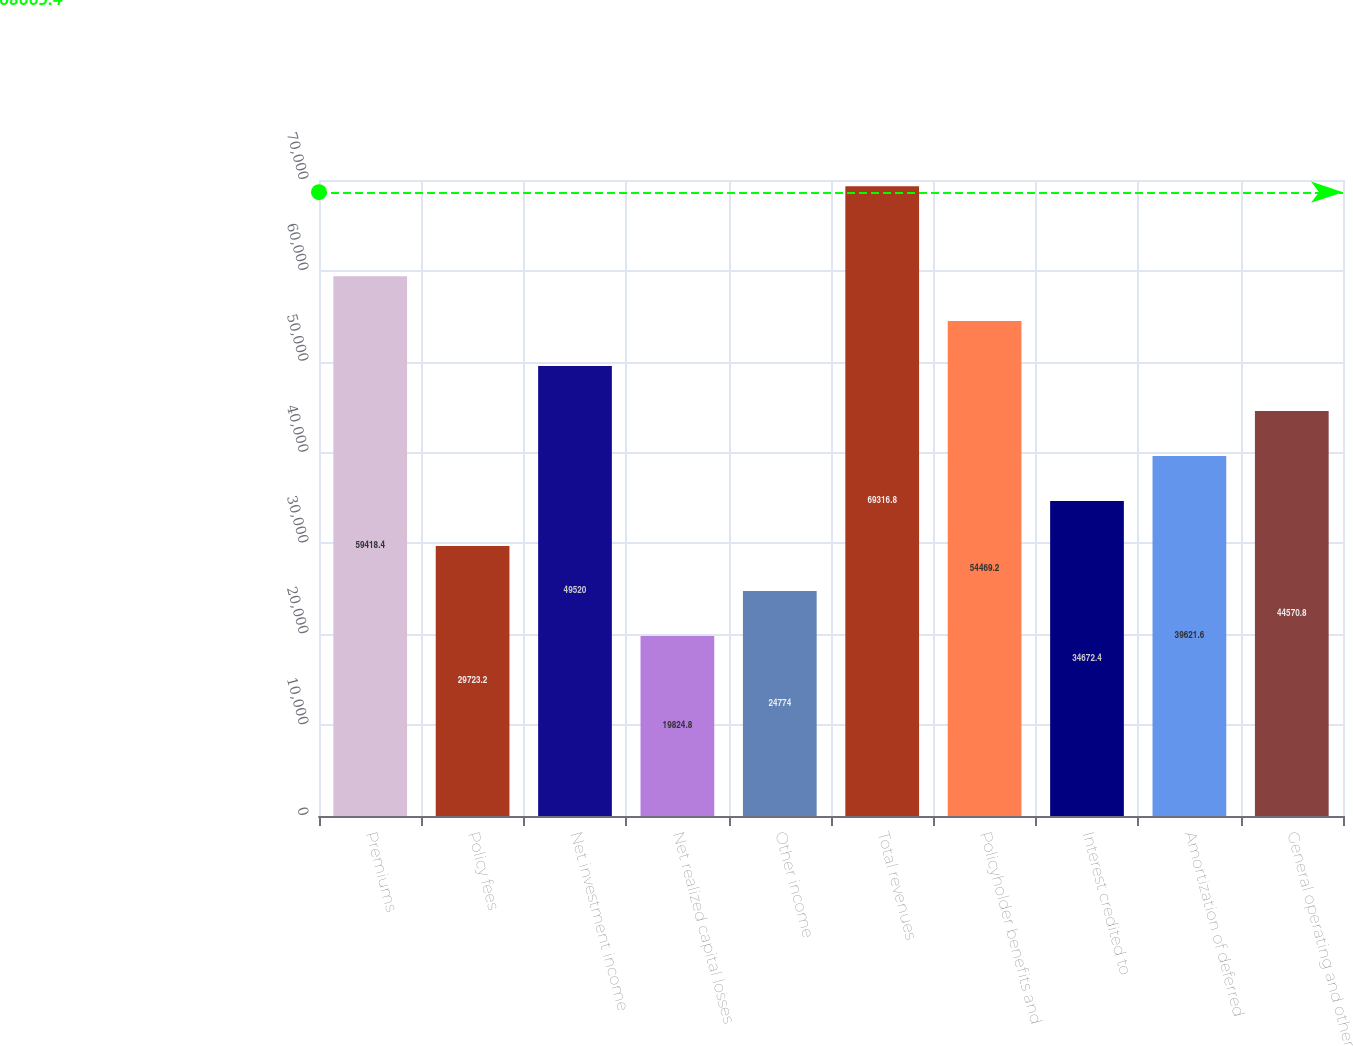<chart> <loc_0><loc_0><loc_500><loc_500><bar_chart><fcel>Premiums<fcel>Policy fees<fcel>Net investment income<fcel>Net realized capital losses<fcel>Other income<fcel>Total revenues<fcel>Policyholder benefits and<fcel>Interest credited to<fcel>Amortization of deferred<fcel>General operating and other<nl><fcel>59418.4<fcel>29723.2<fcel>49520<fcel>19824.8<fcel>24774<fcel>69316.8<fcel>54469.2<fcel>34672.4<fcel>39621.6<fcel>44570.8<nl></chart> 